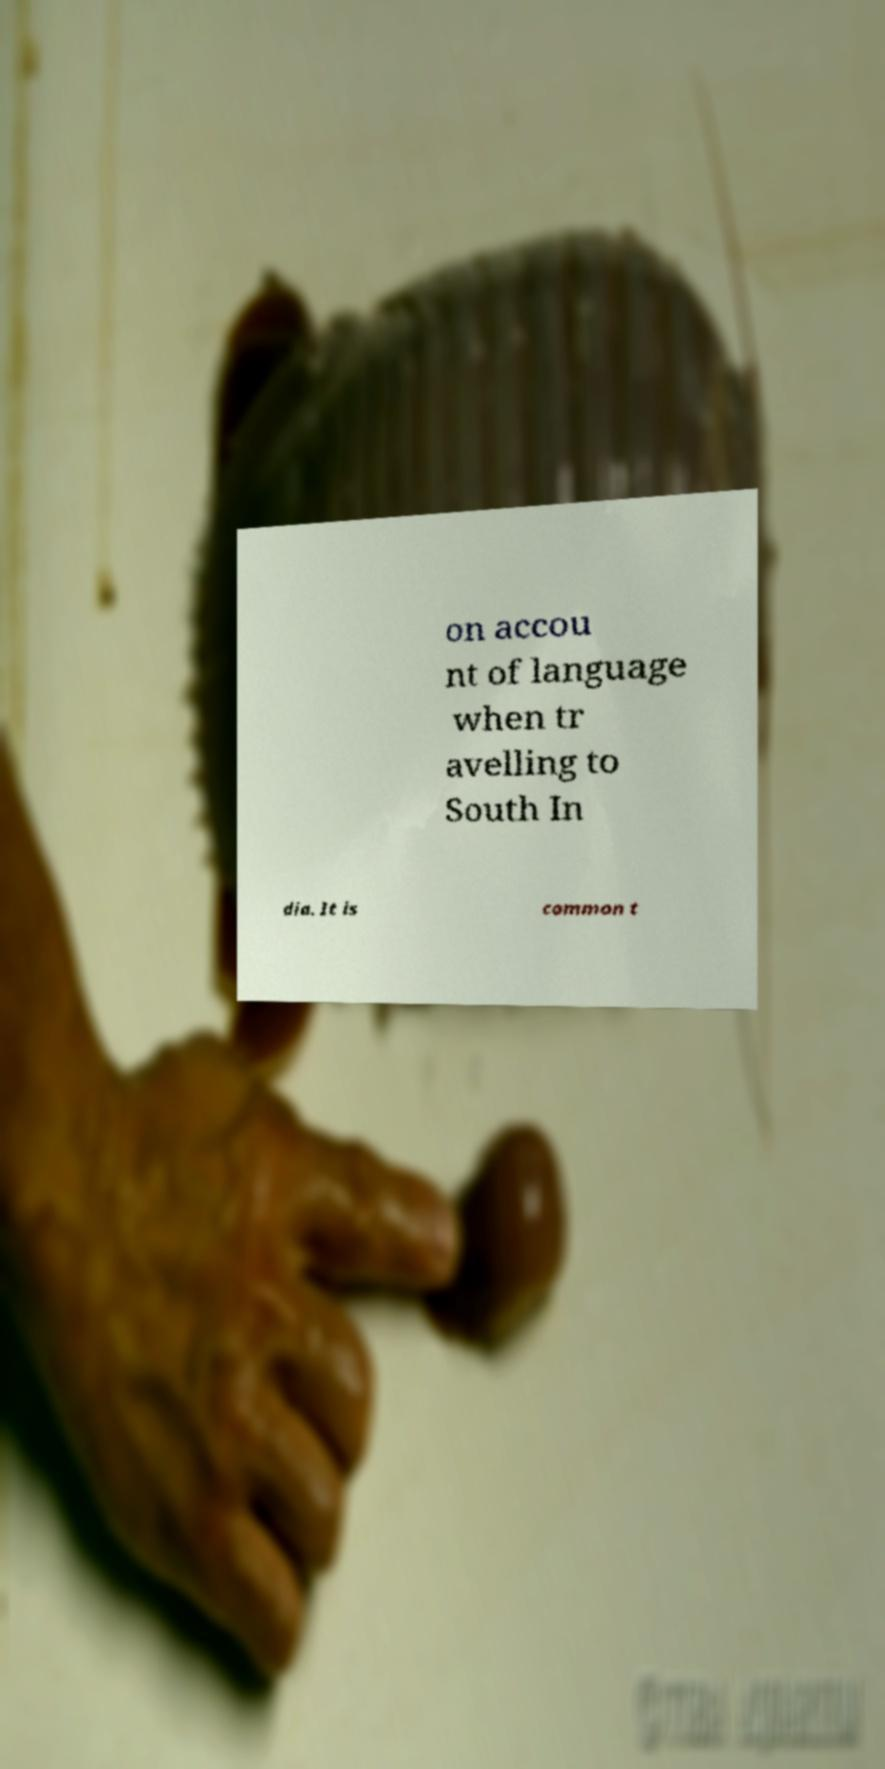Can you read and provide the text displayed in the image?This photo seems to have some interesting text. Can you extract and type it out for me? on accou nt of language when tr avelling to South In dia. It is common t 